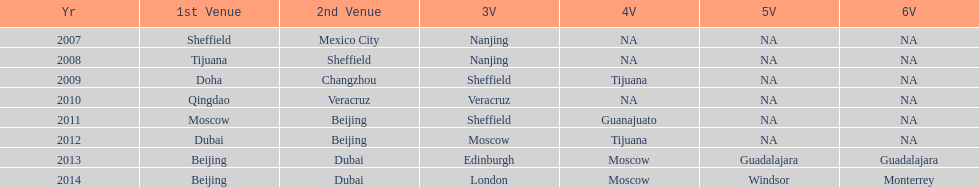Which year is previous to 2011 2010. 